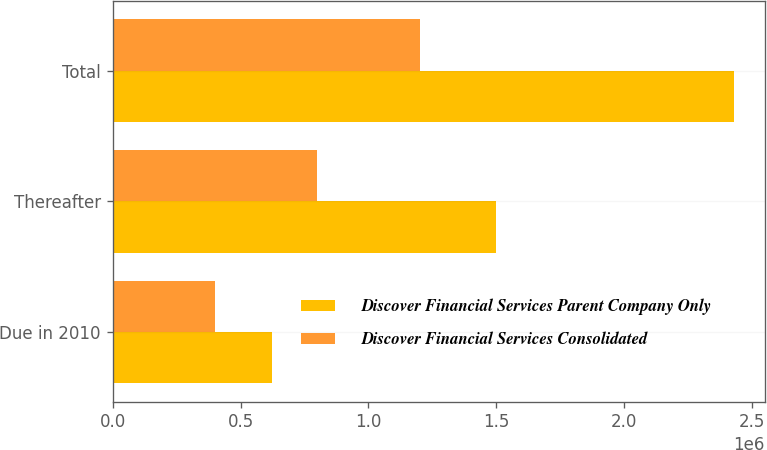<chart> <loc_0><loc_0><loc_500><loc_500><stacked_bar_chart><ecel><fcel>Due in 2010<fcel>Thereafter<fcel>Total<nl><fcel>Discover Financial Services Parent Company Only<fcel>623811<fcel>1.49759e+06<fcel>2.4281e+06<nl><fcel>Discover Financial Services Consolidated<fcel>400000<fcel>799385<fcel>1.19938e+06<nl></chart> 